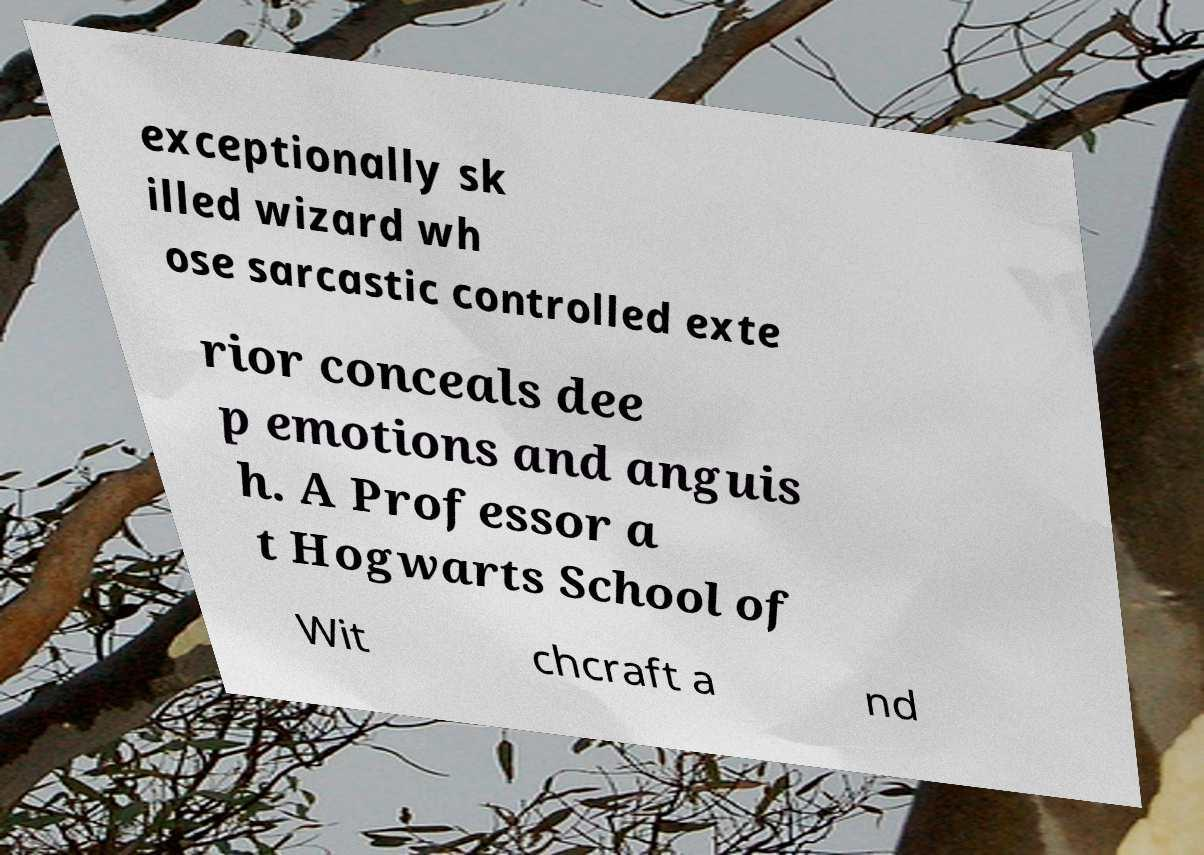Please read and relay the text visible in this image. What does it say? exceptionally sk illed wizard wh ose sarcastic controlled exte rior conceals dee p emotions and anguis h. A Professor a t Hogwarts School of Wit chcraft a nd 